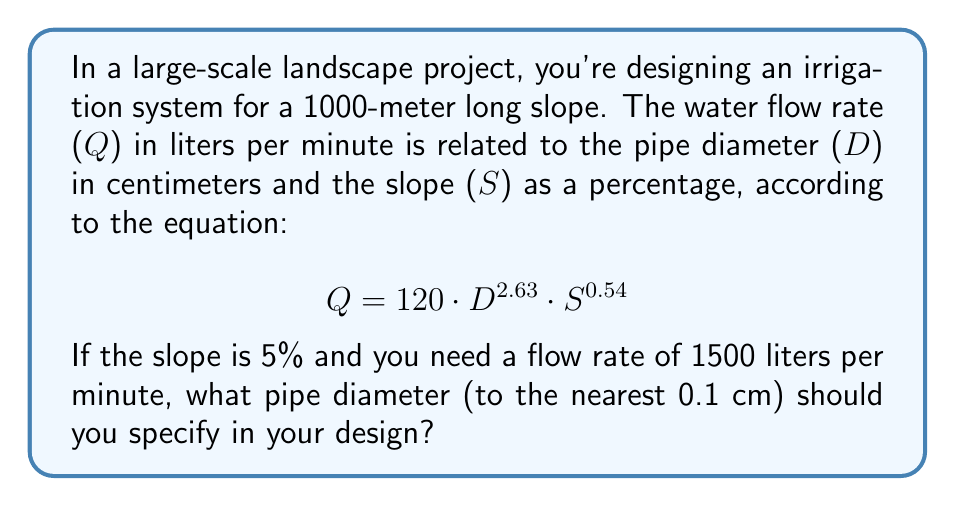Could you help me with this problem? To solve this problem, we'll use the given equation and solve for D:

1) Start with the equation:
   $$ Q = 120 \cdot D^{2.63} \cdot S^{0.54} $$

2) Substitute the known values:
   $$ 1500 = 120 \cdot D^{2.63} \cdot 5^{0.54} $$

3) Simplify the right side:
   $$ 1500 = 120 \cdot D^{2.63} \cdot 2.0581 $$
   $$ 1500 = 246.972 \cdot D^{2.63} $$

4) Divide both sides by 246.972:
   $$ 6.0736 = D^{2.63} $$

5) Take the natural logarithm of both sides:
   $$ \ln(6.0736) = \ln(D^{2.63}) $$
   $$ 1.8040 = 2.63 \cdot \ln(D) $$

6) Divide both sides by 2.63:
   $$ 0.6859 = \ln(D) $$

7) Take the exponential of both sides:
   $$ e^{0.6859} = D $$
   $$ D = 1.9855 \text{ cm} $$

8) Rounding to the nearest 0.1 cm:
   $$ D \approx 2.0 \text{ cm} $$
Answer: 2.0 cm 